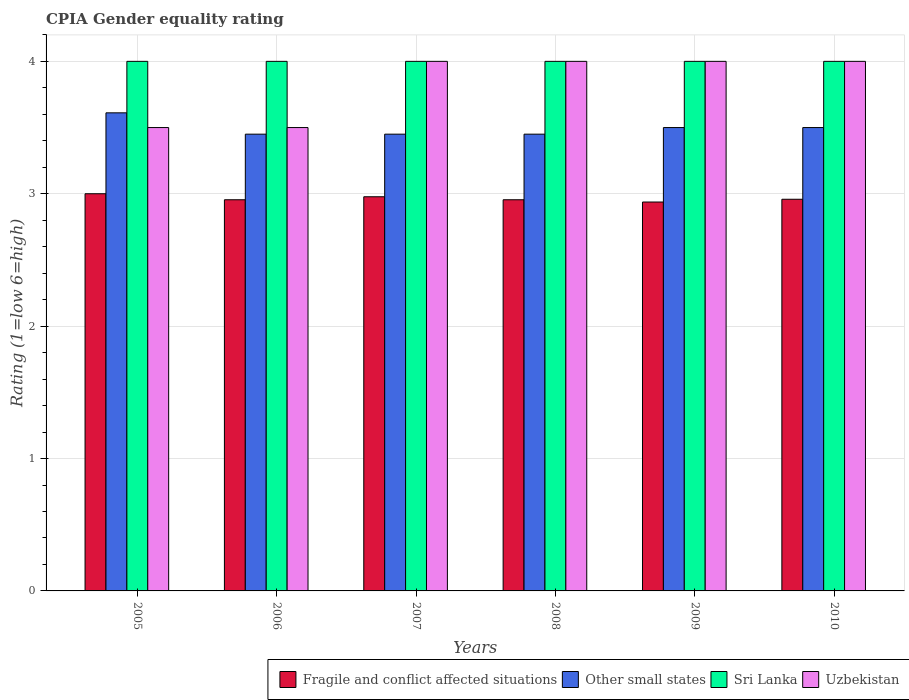How many different coloured bars are there?
Provide a short and direct response. 4. Are the number of bars on each tick of the X-axis equal?
Offer a very short reply. Yes. How many bars are there on the 3rd tick from the right?
Offer a terse response. 4. In how many cases, is the number of bars for a given year not equal to the number of legend labels?
Provide a short and direct response. 0. Across all years, what is the maximum CPIA rating in Sri Lanka?
Provide a succinct answer. 4. Across all years, what is the minimum CPIA rating in Sri Lanka?
Give a very brief answer. 4. In which year was the CPIA rating in Uzbekistan maximum?
Provide a short and direct response. 2007. What is the total CPIA rating in Sri Lanka in the graph?
Keep it short and to the point. 24. What is the difference between the CPIA rating in Sri Lanka in 2008 and that in 2009?
Your response must be concise. 0. What is the difference between the CPIA rating in Other small states in 2008 and the CPIA rating in Fragile and conflict affected situations in 2006?
Offer a very short reply. 0.5. What is the average CPIA rating in Fragile and conflict affected situations per year?
Make the answer very short. 2.96. In the year 2007, what is the difference between the CPIA rating in Uzbekistan and CPIA rating in Sri Lanka?
Offer a terse response. 0. What is the ratio of the CPIA rating in Other small states in 2006 to that in 2010?
Your answer should be very brief. 0.99. Is the CPIA rating in Fragile and conflict affected situations in 2005 less than that in 2009?
Your answer should be compact. No. Is the sum of the CPIA rating in Sri Lanka in 2007 and 2010 greater than the maximum CPIA rating in Fragile and conflict affected situations across all years?
Offer a very short reply. Yes. Is it the case that in every year, the sum of the CPIA rating in Other small states and CPIA rating in Uzbekistan is greater than the sum of CPIA rating in Fragile and conflict affected situations and CPIA rating in Sri Lanka?
Offer a terse response. No. What does the 3rd bar from the left in 2008 represents?
Your response must be concise. Sri Lanka. What does the 2nd bar from the right in 2006 represents?
Your answer should be compact. Sri Lanka. Is it the case that in every year, the sum of the CPIA rating in Other small states and CPIA rating in Fragile and conflict affected situations is greater than the CPIA rating in Uzbekistan?
Provide a succinct answer. Yes. How many bars are there?
Provide a short and direct response. 24. How many years are there in the graph?
Your answer should be compact. 6. Are the values on the major ticks of Y-axis written in scientific E-notation?
Your answer should be compact. No. Does the graph contain any zero values?
Ensure brevity in your answer.  No. What is the title of the graph?
Offer a terse response. CPIA Gender equality rating. Does "Mauritania" appear as one of the legend labels in the graph?
Make the answer very short. No. What is the Rating (1=low 6=high) of Fragile and conflict affected situations in 2005?
Offer a terse response. 3. What is the Rating (1=low 6=high) of Other small states in 2005?
Make the answer very short. 3.61. What is the Rating (1=low 6=high) of Fragile and conflict affected situations in 2006?
Your answer should be compact. 2.95. What is the Rating (1=low 6=high) of Other small states in 2006?
Offer a terse response. 3.45. What is the Rating (1=low 6=high) of Sri Lanka in 2006?
Provide a short and direct response. 4. What is the Rating (1=low 6=high) in Fragile and conflict affected situations in 2007?
Offer a terse response. 2.98. What is the Rating (1=low 6=high) in Other small states in 2007?
Your answer should be very brief. 3.45. What is the Rating (1=low 6=high) of Uzbekistan in 2007?
Keep it short and to the point. 4. What is the Rating (1=low 6=high) in Fragile and conflict affected situations in 2008?
Give a very brief answer. 2.95. What is the Rating (1=low 6=high) of Other small states in 2008?
Your answer should be very brief. 3.45. What is the Rating (1=low 6=high) of Sri Lanka in 2008?
Offer a terse response. 4. What is the Rating (1=low 6=high) in Fragile and conflict affected situations in 2009?
Offer a terse response. 2.94. What is the Rating (1=low 6=high) of Sri Lanka in 2009?
Keep it short and to the point. 4. What is the Rating (1=low 6=high) in Uzbekistan in 2009?
Your response must be concise. 4. What is the Rating (1=low 6=high) of Fragile and conflict affected situations in 2010?
Ensure brevity in your answer.  2.96. What is the Rating (1=low 6=high) in Other small states in 2010?
Provide a short and direct response. 3.5. Across all years, what is the maximum Rating (1=low 6=high) of Fragile and conflict affected situations?
Keep it short and to the point. 3. Across all years, what is the maximum Rating (1=low 6=high) of Other small states?
Your answer should be compact. 3.61. Across all years, what is the maximum Rating (1=low 6=high) in Sri Lanka?
Make the answer very short. 4. Across all years, what is the maximum Rating (1=low 6=high) in Uzbekistan?
Offer a terse response. 4. Across all years, what is the minimum Rating (1=low 6=high) of Fragile and conflict affected situations?
Offer a terse response. 2.94. Across all years, what is the minimum Rating (1=low 6=high) of Other small states?
Provide a short and direct response. 3.45. Across all years, what is the minimum Rating (1=low 6=high) of Sri Lanka?
Keep it short and to the point. 4. Across all years, what is the minimum Rating (1=low 6=high) of Uzbekistan?
Your answer should be compact. 3.5. What is the total Rating (1=low 6=high) in Fragile and conflict affected situations in the graph?
Make the answer very short. 17.78. What is the total Rating (1=low 6=high) of Other small states in the graph?
Ensure brevity in your answer.  20.96. What is the difference between the Rating (1=low 6=high) in Fragile and conflict affected situations in 2005 and that in 2006?
Give a very brief answer. 0.05. What is the difference between the Rating (1=low 6=high) of Other small states in 2005 and that in 2006?
Your response must be concise. 0.16. What is the difference between the Rating (1=low 6=high) in Fragile and conflict affected situations in 2005 and that in 2007?
Keep it short and to the point. 0.02. What is the difference between the Rating (1=low 6=high) in Other small states in 2005 and that in 2007?
Offer a terse response. 0.16. What is the difference between the Rating (1=low 6=high) of Sri Lanka in 2005 and that in 2007?
Make the answer very short. 0. What is the difference between the Rating (1=low 6=high) in Fragile and conflict affected situations in 2005 and that in 2008?
Your answer should be very brief. 0.05. What is the difference between the Rating (1=low 6=high) in Other small states in 2005 and that in 2008?
Provide a short and direct response. 0.16. What is the difference between the Rating (1=low 6=high) of Fragile and conflict affected situations in 2005 and that in 2009?
Your response must be concise. 0.06. What is the difference between the Rating (1=low 6=high) of Other small states in 2005 and that in 2009?
Your response must be concise. 0.11. What is the difference between the Rating (1=low 6=high) in Sri Lanka in 2005 and that in 2009?
Your answer should be very brief. 0. What is the difference between the Rating (1=low 6=high) in Fragile and conflict affected situations in 2005 and that in 2010?
Your answer should be compact. 0.04. What is the difference between the Rating (1=low 6=high) of Sri Lanka in 2005 and that in 2010?
Keep it short and to the point. 0. What is the difference between the Rating (1=low 6=high) in Fragile and conflict affected situations in 2006 and that in 2007?
Offer a very short reply. -0.02. What is the difference between the Rating (1=low 6=high) of Other small states in 2006 and that in 2007?
Offer a terse response. 0. What is the difference between the Rating (1=low 6=high) of Uzbekistan in 2006 and that in 2008?
Ensure brevity in your answer.  -0.5. What is the difference between the Rating (1=low 6=high) of Fragile and conflict affected situations in 2006 and that in 2009?
Offer a very short reply. 0.02. What is the difference between the Rating (1=low 6=high) of Other small states in 2006 and that in 2009?
Provide a succinct answer. -0.05. What is the difference between the Rating (1=low 6=high) of Uzbekistan in 2006 and that in 2009?
Your answer should be very brief. -0.5. What is the difference between the Rating (1=low 6=high) of Fragile and conflict affected situations in 2006 and that in 2010?
Offer a very short reply. -0. What is the difference between the Rating (1=low 6=high) of Sri Lanka in 2006 and that in 2010?
Provide a short and direct response. 0. What is the difference between the Rating (1=low 6=high) in Fragile and conflict affected situations in 2007 and that in 2008?
Your response must be concise. 0.02. What is the difference between the Rating (1=low 6=high) of Other small states in 2007 and that in 2008?
Your response must be concise. 0. What is the difference between the Rating (1=low 6=high) of Fragile and conflict affected situations in 2007 and that in 2009?
Your answer should be compact. 0.04. What is the difference between the Rating (1=low 6=high) of Sri Lanka in 2007 and that in 2009?
Your answer should be compact. 0. What is the difference between the Rating (1=low 6=high) in Fragile and conflict affected situations in 2007 and that in 2010?
Offer a terse response. 0.02. What is the difference between the Rating (1=low 6=high) in Uzbekistan in 2007 and that in 2010?
Offer a very short reply. 0. What is the difference between the Rating (1=low 6=high) of Fragile and conflict affected situations in 2008 and that in 2009?
Your response must be concise. 0.02. What is the difference between the Rating (1=low 6=high) in Uzbekistan in 2008 and that in 2009?
Your response must be concise. 0. What is the difference between the Rating (1=low 6=high) in Fragile and conflict affected situations in 2008 and that in 2010?
Your answer should be very brief. -0. What is the difference between the Rating (1=low 6=high) of Uzbekistan in 2008 and that in 2010?
Your answer should be very brief. 0. What is the difference between the Rating (1=low 6=high) in Fragile and conflict affected situations in 2009 and that in 2010?
Ensure brevity in your answer.  -0.02. What is the difference between the Rating (1=low 6=high) of Other small states in 2009 and that in 2010?
Give a very brief answer. 0. What is the difference between the Rating (1=low 6=high) in Sri Lanka in 2009 and that in 2010?
Give a very brief answer. 0. What is the difference between the Rating (1=low 6=high) of Fragile and conflict affected situations in 2005 and the Rating (1=low 6=high) of Other small states in 2006?
Your answer should be very brief. -0.45. What is the difference between the Rating (1=low 6=high) of Fragile and conflict affected situations in 2005 and the Rating (1=low 6=high) of Uzbekistan in 2006?
Provide a short and direct response. -0.5. What is the difference between the Rating (1=low 6=high) of Other small states in 2005 and the Rating (1=low 6=high) of Sri Lanka in 2006?
Offer a terse response. -0.39. What is the difference between the Rating (1=low 6=high) in Other small states in 2005 and the Rating (1=low 6=high) in Uzbekistan in 2006?
Offer a very short reply. 0.11. What is the difference between the Rating (1=low 6=high) in Sri Lanka in 2005 and the Rating (1=low 6=high) in Uzbekistan in 2006?
Make the answer very short. 0.5. What is the difference between the Rating (1=low 6=high) in Fragile and conflict affected situations in 2005 and the Rating (1=low 6=high) in Other small states in 2007?
Keep it short and to the point. -0.45. What is the difference between the Rating (1=low 6=high) of Fragile and conflict affected situations in 2005 and the Rating (1=low 6=high) of Sri Lanka in 2007?
Make the answer very short. -1. What is the difference between the Rating (1=low 6=high) in Fragile and conflict affected situations in 2005 and the Rating (1=low 6=high) in Uzbekistan in 2007?
Your answer should be very brief. -1. What is the difference between the Rating (1=low 6=high) of Other small states in 2005 and the Rating (1=low 6=high) of Sri Lanka in 2007?
Provide a succinct answer. -0.39. What is the difference between the Rating (1=low 6=high) of Other small states in 2005 and the Rating (1=low 6=high) of Uzbekistan in 2007?
Offer a very short reply. -0.39. What is the difference between the Rating (1=low 6=high) of Fragile and conflict affected situations in 2005 and the Rating (1=low 6=high) of Other small states in 2008?
Your response must be concise. -0.45. What is the difference between the Rating (1=low 6=high) in Fragile and conflict affected situations in 2005 and the Rating (1=low 6=high) in Sri Lanka in 2008?
Make the answer very short. -1. What is the difference between the Rating (1=low 6=high) of Fragile and conflict affected situations in 2005 and the Rating (1=low 6=high) of Uzbekistan in 2008?
Your response must be concise. -1. What is the difference between the Rating (1=low 6=high) in Other small states in 2005 and the Rating (1=low 6=high) in Sri Lanka in 2008?
Provide a succinct answer. -0.39. What is the difference between the Rating (1=low 6=high) of Other small states in 2005 and the Rating (1=low 6=high) of Uzbekistan in 2008?
Ensure brevity in your answer.  -0.39. What is the difference between the Rating (1=low 6=high) in Fragile and conflict affected situations in 2005 and the Rating (1=low 6=high) in Sri Lanka in 2009?
Your response must be concise. -1. What is the difference between the Rating (1=low 6=high) in Other small states in 2005 and the Rating (1=low 6=high) in Sri Lanka in 2009?
Offer a terse response. -0.39. What is the difference between the Rating (1=low 6=high) of Other small states in 2005 and the Rating (1=low 6=high) of Uzbekistan in 2009?
Provide a short and direct response. -0.39. What is the difference between the Rating (1=low 6=high) of Fragile and conflict affected situations in 2005 and the Rating (1=low 6=high) of Other small states in 2010?
Offer a terse response. -0.5. What is the difference between the Rating (1=low 6=high) in Other small states in 2005 and the Rating (1=low 6=high) in Sri Lanka in 2010?
Make the answer very short. -0.39. What is the difference between the Rating (1=low 6=high) in Other small states in 2005 and the Rating (1=low 6=high) in Uzbekistan in 2010?
Your answer should be compact. -0.39. What is the difference between the Rating (1=low 6=high) of Fragile and conflict affected situations in 2006 and the Rating (1=low 6=high) of Other small states in 2007?
Keep it short and to the point. -0.5. What is the difference between the Rating (1=low 6=high) of Fragile and conflict affected situations in 2006 and the Rating (1=low 6=high) of Sri Lanka in 2007?
Your answer should be very brief. -1.05. What is the difference between the Rating (1=low 6=high) in Fragile and conflict affected situations in 2006 and the Rating (1=low 6=high) in Uzbekistan in 2007?
Give a very brief answer. -1.05. What is the difference between the Rating (1=low 6=high) in Other small states in 2006 and the Rating (1=low 6=high) in Sri Lanka in 2007?
Offer a very short reply. -0.55. What is the difference between the Rating (1=low 6=high) in Other small states in 2006 and the Rating (1=low 6=high) in Uzbekistan in 2007?
Offer a very short reply. -0.55. What is the difference between the Rating (1=low 6=high) of Sri Lanka in 2006 and the Rating (1=low 6=high) of Uzbekistan in 2007?
Ensure brevity in your answer.  0. What is the difference between the Rating (1=low 6=high) of Fragile and conflict affected situations in 2006 and the Rating (1=low 6=high) of Other small states in 2008?
Give a very brief answer. -0.5. What is the difference between the Rating (1=low 6=high) of Fragile and conflict affected situations in 2006 and the Rating (1=low 6=high) of Sri Lanka in 2008?
Your answer should be compact. -1.05. What is the difference between the Rating (1=low 6=high) of Fragile and conflict affected situations in 2006 and the Rating (1=low 6=high) of Uzbekistan in 2008?
Ensure brevity in your answer.  -1.05. What is the difference between the Rating (1=low 6=high) in Other small states in 2006 and the Rating (1=low 6=high) in Sri Lanka in 2008?
Provide a short and direct response. -0.55. What is the difference between the Rating (1=low 6=high) of Other small states in 2006 and the Rating (1=low 6=high) of Uzbekistan in 2008?
Offer a very short reply. -0.55. What is the difference between the Rating (1=low 6=high) of Sri Lanka in 2006 and the Rating (1=low 6=high) of Uzbekistan in 2008?
Your response must be concise. 0. What is the difference between the Rating (1=low 6=high) in Fragile and conflict affected situations in 2006 and the Rating (1=low 6=high) in Other small states in 2009?
Provide a succinct answer. -0.55. What is the difference between the Rating (1=low 6=high) in Fragile and conflict affected situations in 2006 and the Rating (1=low 6=high) in Sri Lanka in 2009?
Offer a very short reply. -1.05. What is the difference between the Rating (1=low 6=high) in Fragile and conflict affected situations in 2006 and the Rating (1=low 6=high) in Uzbekistan in 2009?
Provide a short and direct response. -1.05. What is the difference between the Rating (1=low 6=high) of Other small states in 2006 and the Rating (1=low 6=high) of Sri Lanka in 2009?
Provide a short and direct response. -0.55. What is the difference between the Rating (1=low 6=high) in Other small states in 2006 and the Rating (1=low 6=high) in Uzbekistan in 2009?
Give a very brief answer. -0.55. What is the difference between the Rating (1=low 6=high) in Sri Lanka in 2006 and the Rating (1=low 6=high) in Uzbekistan in 2009?
Make the answer very short. 0. What is the difference between the Rating (1=low 6=high) of Fragile and conflict affected situations in 2006 and the Rating (1=low 6=high) of Other small states in 2010?
Keep it short and to the point. -0.55. What is the difference between the Rating (1=low 6=high) of Fragile and conflict affected situations in 2006 and the Rating (1=low 6=high) of Sri Lanka in 2010?
Offer a very short reply. -1.05. What is the difference between the Rating (1=low 6=high) in Fragile and conflict affected situations in 2006 and the Rating (1=low 6=high) in Uzbekistan in 2010?
Your answer should be very brief. -1.05. What is the difference between the Rating (1=low 6=high) in Other small states in 2006 and the Rating (1=low 6=high) in Sri Lanka in 2010?
Your answer should be compact. -0.55. What is the difference between the Rating (1=low 6=high) of Other small states in 2006 and the Rating (1=low 6=high) of Uzbekistan in 2010?
Offer a terse response. -0.55. What is the difference between the Rating (1=low 6=high) of Sri Lanka in 2006 and the Rating (1=low 6=high) of Uzbekistan in 2010?
Your answer should be compact. 0. What is the difference between the Rating (1=low 6=high) of Fragile and conflict affected situations in 2007 and the Rating (1=low 6=high) of Other small states in 2008?
Provide a succinct answer. -0.47. What is the difference between the Rating (1=low 6=high) in Fragile and conflict affected situations in 2007 and the Rating (1=low 6=high) in Sri Lanka in 2008?
Provide a short and direct response. -1.02. What is the difference between the Rating (1=low 6=high) in Fragile and conflict affected situations in 2007 and the Rating (1=low 6=high) in Uzbekistan in 2008?
Offer a very short reply. -1.02. What is the difference between the Rating (1=low 6=high) of Other small states in 2007 and the Rating (1=low 6=high) of Sri Lanka in 2008?
Make the answer very short. -0.55. What is the difference between the Rating (1=low 6=high) of Other small states in 2007 and the Rating (1=low 6=high) of Uzbekistan in 2008?
Your response must be concise. -0.55. What is the difference between the Rating (1=low 6=high) of Sri Lanka in 2007 and the Rating (1=low 6=high) of Uzbekistan in 2008?
Your response must be concise. 0. What is the difference between the Rating (1=low 6=high) in Fragile and conflict affected situations in 2007 and the Rating (1=low 6=high) in Other small states in 2009?
Offer a terse response. -0.52. What is the difference between the Rating (1=low 6=high) in Fragile and conflict affected situations in 2007 and the Rating (1=low 6=high) in Sri Lanka in 2009?
Ensure brevity in your answer.  -1.02. What is the difference between the Rating (1=low 6=high) of Fragile and conflict affected situations in 2007 and the Rating (1=low 6=high) of Uzbekistan in 2009?
Your answer should be compact. -1.02. What is the difference between the Rating (1=low 6=high) in Other small states in 2007 and the Rating (1=low 6=high) in Sri Lanka in 2009?
Keep it short and to the point. -0.55. What is the difference between the Rating (1=low 6=high) of Other small states in 2007 and the Rating (1=low 6=high) of Uzbekistan in 2009?
Ensure brevity in your answer.  -0.55. What is the difference between the Rating (1=low 6=high) of Sri Lanka in 2007 and the Rating (1=low 6=high) of Uzbekistan in 2009?
Keep it short and to the point. 0. What is the difference between the Rating (1=low 6=high) in Fragile and conflict affected situations in 2007 and the Rating (1=low 6=high) in Other small states in 2010?
Offer a terse response. -0.52. What is the difference between the Rating (1=low 6=high) of Fragile and conflict affected situations in 2007 and the Rating (1=low 6=high) of Sri Lanka in 2010?
Your answer should be very brief. -1.02. What is the difference between the Rating (1=low 6=high) in Fragile and conflict affected situations in 2007 and the Rating (1=low 6=high) in Uzbekistan in 2010?
Your answer should be compact. -1.02. What is the difference between the Rating (1=low 6=high) of Other small states in 2007 and the Rating (1=low 6=high) of Sri Lanka in 2010?
Make the answer very short. -0.55. What is the difference between the Rating (1=low 6=high) in Other small states in 2007 and the Rating (1=low 6=high) in Uzbekistan in 2010?
Provide a short and direct response. -0.55. What is the difference between the Rating (1=low 6=high) in Fragile and conflict affected situations in 2008 and the Rating (1=low 6=high) in Other small states in 2009?
Your answer should be very brief. -0.55. What is the difference between the Rating (1=low 6=high) of Fragile and conflict affected situations in 2008 and the Rating (1=low 6=high) of Sri Lanka in 2009?
Make the answer very short. -1.05. What is the difference between the Rating (1=low 6=high) of Fragile and conflict affected situations in 2008 and the Rating (1=low 6=high) of Uzbekistan in 2009?
Provide a succinct answer. -1.05. What is the difference between the Rating (1=low 6=high) of Other small states in 2008 and the Rating (1=low 6=high) of Sri Lanka in 2009?
Provide a succinct answer. -0.55. What is the difference between the Rating (1=low 6=high) in Other small states in 2008 and the Rating (1=low 6=high) in Uzbekistan in 2009?
Keep it short and to the point. -0.55. What is the difference between the Rating (1=low 6=high) in Sri Lanka in 2008 and the Rating (1=low 6=high) in Uzbekistan in 2009?
Offer a very short reply. 0. What is the difference between the Rating (1=low 6=high) of Fragile and conflict affected situations in 2008 and the Rating (1=low 6=high) of Other small states in 2010?
Make the answer very short. -0.55. What is the difference between the Rating (1=low 6=high) in Fragile and conflict affected situations in 2008 and the Rating (1=low 6=high) in Sri Lanka in 2010?
Offer a terse response. -1.05. What is the difference between the Rating (1=low 6=high) of Fragile and conflict affected situations in 2008 and the Rating (1=low 6=high) of Uzbekistan in 2010?
Your answer should be compact. -1.05. What is the difference between the Rating (1=low 6=high) in Other small states in 2008 and the Rating (1=low 6=high) in Sri Lanka in 2010?
Your answer should be compact. -0.55. What is the difference between the Rating (1=low 6=high) of Other small states in 2008 and the Rating (1=low 6=high) of Uzbekistan in 2010?
Your answer should be compact. -0.55. What is the difference between the Rating (1=low 6=high) of Sri Lanka in 2008 and the Rating (1=low 6=high) of Uzbekistan in 2010?
Ensure brevity in your answer.  0. What is the difference between the Rating (1=low 6=high) in Fragile and conflict affected situations in 2009 and the Rating (1=low 6=high) in Other small states in 2010?
Your answer should be very brief. -0.56. What is the difference between the Rating (1=low 6=high) of Fragile and conflict affected situations in 2009 and the Rating (1=low 6=high) of Sri Lanka in 2010?
Ensure brevity in your answer.  -1.06. What is the difference between the Rating (1=low 6=high) of Fragile and conflict affected situations in 2009 and the Rating (1=low 6=high) of Uzbekistan in 2010?
Your answer should be very brief. -1.06. What is the difference between the Rating (1=low 6=high) in Other small states in 2009 and the Rating (1=low 6=high) in Sri Lanka in 2010?
Keep it short and to the point. -0.5. What is the difference between the Rating (1=low 6=high) in Other small states in 2009 and the Rating (1=low 6=high) in Uzbekistan in 2010?
Provide a succinct answer. -0.5. What is the difference between the Rating (1=low 6=high) of Sri Lanka in 2009 and the Rating (1=low 6=high) of Uzbekistan in 2010?
Offer a very short reply. 0. What is the average Rating (1=low 6=high) in Fragile and conflict affected situations per year?
Make the answer very short. 2.96. What is the average Rating (1=low 6=high) of Other small states per year?
Your response must be concise. 3.49. What is the average Rating (1=low 6=high) in Sri Lanka per year?
Provide a short and direct response. 4. What is the average Rating (1=low 6=high) of Uzbekistan per year?
Your response must be concise. 3.83. In the year 2005, what is the difference between the Rating (1=low 6=high) of Fragile and conflict affected situations and Rating (1=low 6=high) of Other small states?
Provide a short and direct response. -0.61. In the year 2005, what is the difference between the Rating (1=low 6=high) of Other small states and Rating (1=low 6=high) of Sri Lanka?
Your answer should be compact. -0.39. In the year 2005, what is the difference between the Rating (1=low 6=high) in Other small states and Rating (1=low 6=high) in Uzbekistan?
Your answer should be compact. 0.11. In the year 2006, what is the difference between the Rating (1=low 6=high) of Fragile and conflict affected situations and Rating (1=low 6=high) of Other small states?
Provide a succinct answer. -0.5. In the year 2006, what is the difference between the Rating (1=low 6=high) in Fragile and conflict affected situations and Rating (1=low 6=high) in Sri Lanka?
Keep it short and to the point. -1.05. In the year 2006, what is the difference between the Rating (1=low 6=high) of Fragile and conflict affected situations and Rating (1=low 6=high) of Uzbekistan?
Your answer should be compact. -0.55. In the year 2006, what is the difference between the Rating (1=low 6=high) in Other small states and Rating (1=low 6=high) in Sri Lanka?
Offer a very short reply. -0.55. In the year 2006, what is the difference between the Rating (1=low 6=high) in Other small states and Rating (1=low 6=high) in Uzbekistan?
Make the answer very short. -0.05. In the year 2006, what is the difference between the Rating (1=low 6=high) of Sri Lanka and Rating (1=low 6=high) of Uzbekistan?
Your response must be concise. 0.5. In the year 2007, what is the difference between the Rating (1=low 6=high) in Fragile and conflict affected situations and Rating (1=low 6=high) in Other small states?
Provide a succinct answer. -0.47. In the year 2007, what is the difference between the Rating (1=low 6=high) of Fragile and conflict affected situations and Rating (1=low 6=high) of Sri Lanka?
Provide a succinct answer. -1.02. In the year 2007, what is the difference between the Rating (1=low 6=high) of Fragile and conflict affected situations and Rating (1=low 6=high) of Uzbekistan?
Ensure brevity in your answer.  -1.02. In the year 2007, what is the difference between the Rating (1=low 6=high) in Other small states and Rating (1=low 6=high) in Sri Lanka?
Make the answer very short. -0.55. In the year 2007, what is the difference between the Rating (1=low 6=high) of Other small states and Rating (1=low 6=high) of Uzbekistan?
Make the answer very short. -0.55. In the year 2008, what is the difference between the Rating (1=low 6=high) of Fragile and conflict affected situations and Rating (1=low 6=high) of Other small states?
Provide a short and direct response. -0.5. In the year 2008, what is the difference between the Rating (1=low 6=high) in Fragile and conflict affected situations and Rating (1=low 6=high) in Sri Lanka?
Your answer should be compact. -1.05. In the year 2008, what is the difference between the Rating (1=low 6=high) in Fragile and conflict affected situations and Rating (1=low 6=high) in Uzbekistan?
Ensure brevity in your answer.  -1.05. In the year 2008, what is the difference between the Rating (1=low 6=high) of Other small states and Rating (1=low 6=high) of Sri Lanka?
Your answer should be very brief. -0.55. In the year 2008, what is the difference between the Rating (1=low 6=high) in Other small states and Rating (1=low 6=high) in Uzbekistan?
Keep it short and to the point. -0.55. In the year 2009, what is the difference between the Rating (1=low 6=high) of Fragile and conflict affected situations and Rating (1=low 6=high) of Other small states?
Provide a short and direct response. -0.56. In the year 2009, what is the difference between the Rating (1=low 6=high) of Fragile and conflict affected situations and Rating (1=low 6=high) of Sri Lanka?
Offer a very short reply. -1.06. In the year 2009, what is the difference between the Rating (1=low 6=high) of Fragile and conflict affected situations and Rating (1=low 6=high) of Uzbekistan?
Provide a short and direct response. -1.06. In the year 2009, what is the difference between the Rating (1=low 6=high) of Other small states and Rating (1=low 6=high) of Uzbekistan?
Keep it short and to the point. -0.5. In the year 2010, what is the difference between the Rating (1=low 6=high) of Fragile and conflict affected situations and Rating (1=low 6=high) of Other small states?
Provide a short and direct response. -0.54. In the year 2010, what is the difference between the Rating (1=low 6=high) in Fragile and conflict affected situations and Rating (1=low 6=high) in Sri Lanka?
Your answer should be compact. -1.04. In the year 2010, what is the difference between the Rating (1=low 6=high) in Fragile and conflict affected situations and Rating (1=low 6=high) in Uzbekistan?
Provide a succinct answer. -1.04. In the year 2010, what is the difference between the Rating (1=low 6=high) of Other small states and Rating (1=low 6=high) of Sri Lanka?
Offer a terse response. -0.5. In the year 2010, what is the difference between the Rating (1=low 6=high) in Other small states and Rating (1=low 6=high) in Uzbekistan?
Provide a short and direct response. -0.5. In the year 2010, what is the difference between the Rating (1=low 6=high) in Sri Lanka and Rating (1=low 6=high) in Uzbekistan?
Ensure brevity in your answer.  0. What is the ratio of the Rating (1=low 6=high) in Fragile and conflict affected situations in 2005 to that in 2006?
Provide a succinct answer. 1.02. What is the ratio of the Rating (1=low 6=high) of Other small states in 2005 to that in 2006?
Offer a very short reply. 1.05. What is the ratio of the Rating (1=low 6=high) in Uzbekistan in 2005 to that in 2006?
Provide a succinct answer. 1. What is the ratio of the Rating (1=low 6=high) of Fragile and conflict affected situations in 2005 to that in 2007?
Your answer should be very brief. 1.01. What is the ratio of the Rating (1=low 6=high) in Other small states in 2005 to that in 2007?
Ensure brevity in your answer.  1.05. What is the ratio of the Rating (1=low 6=high) in Sri Lanka in 2005 to that in 2007?
Your answer should be very brief. 1. What is the ratio of the Rating (1=low 6=high) in Uzbekistan in 2005 to that in 2007?
Offer a very short reply. 0.88. What is the ratio of the Rating (1=low 6=high) in Fragile and conflict affected situations in 2005 to that in 2008?
Provide a short and direct response. 1.02. What is the ratio of the Rating (1=low 6=high) in Other small states in 2005 to that in 2008?
Offer a very short reply. 1.05. What is the ratio of the Rating (1=low 6=high) of Sri Lanka in 2005 to that in 2008?
Keep it short and to the point. 1. What is the ratio of the Rating (1=low 6=high) of Uzbekistan in 2005 to that in 2008?
Ensure brevity in your answer.  0.88. What is the ratio of the Rating (1=low 6=high) of Fragile and conflict affected situations in 2005 to that in 2009?
Offer a very short reply. 1.02. What is the ratio of the Rating (1=low 6=high) of Other small states in 2005 to that in 2009?
Your answer should be compact. 1.03. What is the ratio of the Rating (1=low 6=high) of Sri Lanka in 2005 to that in 2009?
Keep it short and to the point. 1. What is the ratio of the Rating (1=low 6=high) of Uzbekistan in 2005 to that in 2009?
Your answer should be very brief. 0.88. What is the ratio of the Rating (1=low 6=high) in Fragile and conflict affected situations in 2005 to that in 2010?
Your answer should be very brief. 1.01. What is the ratio of the Rating (1=low 6=high) of Other small states in 2005 to that in 2010?
Your response must be concise. 1.03. What is the ratio of the Rating (1=low 6=high) of Sri Lanka in 2005 to that in 2010?
Your response must be concise. 1. What is the ratio of the Rating (1=low 6=high) of Sri Lanka in 2006 to that in 2007?
Provide a short and direct response. 1. What is the ratio of the Rating (1=low 6=high) of Uzbekistan in 2006 to that in 2007?
Give a very brief answer. 0.88. What is the ratio of the Rating (1=low 6=high) in Sri Lanka in 2006 to that in 2008?
Provide a short and direct response. 1. What is the ratio of the Rating (1=low 6=high) in Other small states in 2006 to that in 2009?
Your response must be concise. 0.99. What is the ratio of the Rating (1=low 6=high) of Fragile and conflict affected situations in 2006 to that in 2010?
Your response must be concise. 1. What is the ratio of the Rating (1=low 6=high) in Other small states in 2006 to that in 2010?
Keep it short and to the point. 0.99. What is the ratio of the Rating (1=low 6=high) in Sri Lanka in 2006 to that in 2010?
Offer a very short reply. 1. What is the ratio of the Rating (1=low 6=high) of Uzbekistan in 2006 to that in 2010?
Your answer should be compact. 0.88. What is the ratio of the Rating (1=low 6=high) in Fragile and conflict affected situations in 2007 to that in 2008?
Your response must be concise. 1.01. What is the ratio of the Rating (1=low 6=high) of Fragile and conflict affected situations in 2007 to that in 2009?
Offer a terse response. 1.01. What is the ratio of the Rating (1=low 6=high) in Other small states in 2007 to that in 2009?
Ensure brevity in your answer.  0.99. What is the ratio of the Rating (1=low 6=high) in Fragile and conflict affected situations in 2007 to that in 2010?
Provide a succinct answer. 1.01. What is the ratio of the Rating (1=low 6=high) in Other small states in 2007 to that in 2010?
Offer a terse response. 0.99. What is the ratio of the Rating (1=low 6=high) in Uzbekistan in 2007 to that in 2010?
Provide a short and direct response. 1. What is the ratio of the Rating (1=low 6=high) of Fragile and conflict affected situations in 2008 to that in 2009?
Your answer should be very brief. 1.01. What is the ratio of the Rating (1=low 6=high) of Other small states in 2008 to that in 2009?
Your answer should be very brief. 0.99. What is the ratio of the Rating (1=low 6=high) of Other small states in 2008 to that in 2010?
Your answer should be very brief. 0.99. What is the ratio of the Rating (1=low 6=high) in Sri Lanka in 2008 to that in 2010?
Give a very brief answer. 1. What is the ratio of the Rating (1=low 6=high) of Fragile and conflict affected situations in 2009 to that in 2010?
Your answer should be very brief. 0.99. What is the ratio of the Rating (1=low 6=high) in Sri Lanka in 2009 to that in 2010?
Your response must be concise. 1. What is the difference between the highest and the second highest Rating (1=low 6=high) of Fragile and conflict affected situations?
Give a very brief answer. 0.02. What is the difference between the highest and the second highest Rating (1=low 6=high) in Other small states?
Give a very brief answer. 0.11. What is the difference between the highest and the second highest Rating (1=low 6=high) of Sri Lanka?
Offer a terse response. 0. What is the difference between the highest and the second highest Rating (1=low 6=high) of Uzbekistan?
Provide a short and direct response. 0. What is the difference between the highest and the lowest Rating (1=low 6=high) of Fragile and conflict affected situations?
Keep it short and to the point. 0.06. What is the difference between the highest and the lowest Rating (1=low 6=high) in Other small states?
Your answer should be very brief. 0.16. What is the difference between the highest and the lowest Rating (1=low 6=high) of Sri Lanka?
Offer a very short reply. 0. 